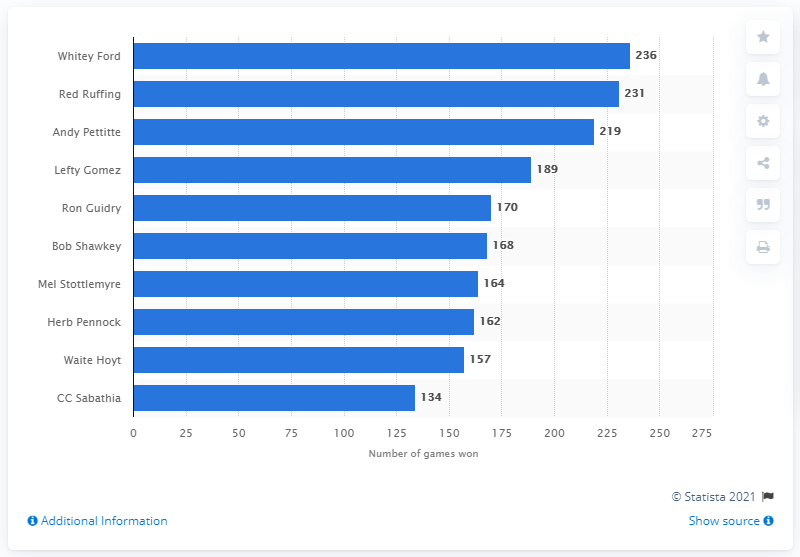Point out several critical features in this image. The New York Yankees franchise has a rich history of winning, with one player standing out as the all-time leader in game victories. That player is Whitey Ford, who holds the record for the most games won by a Yankees pitcher with 198 career wins. Whitey Ford has won the most games in New York Yankees history with 236 victories. 